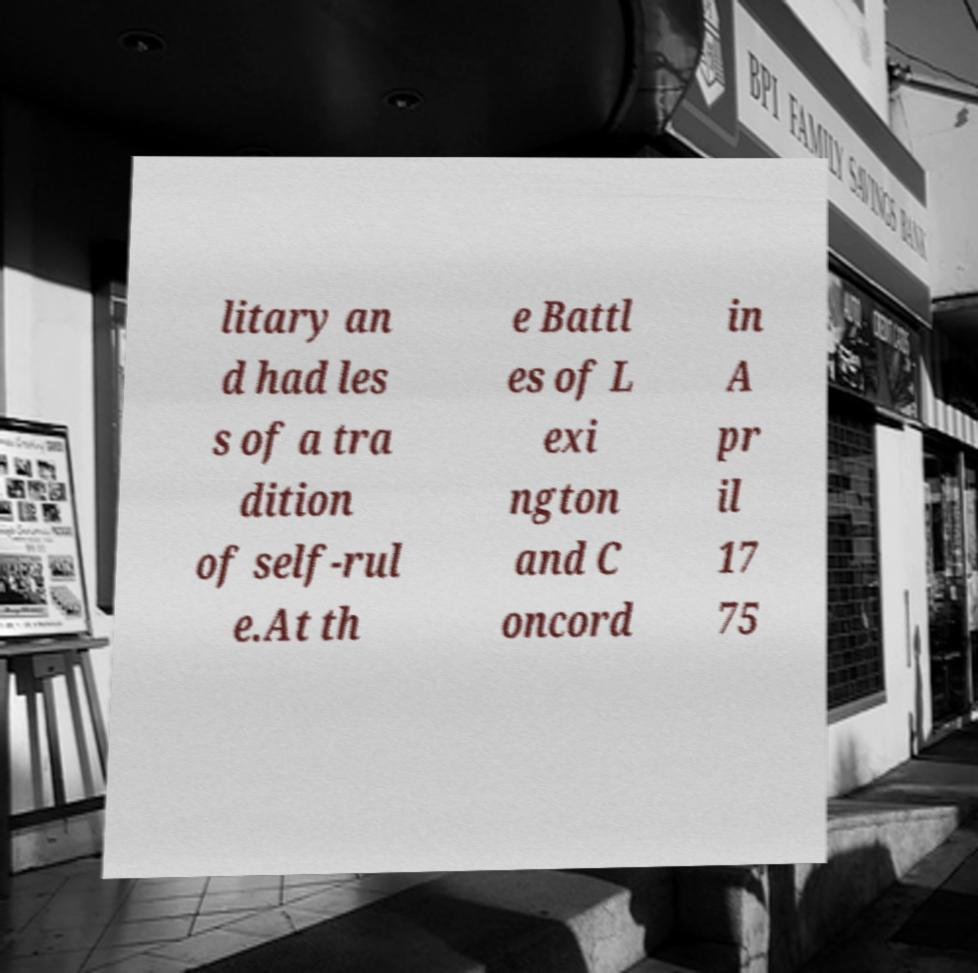Could you assist in decoding the text presented in this image and type it out clearly? litary an d had les s of a tra dition of self-rul e.At th e Battl es of L exi ngton and C oncord in A pr il 17 75 